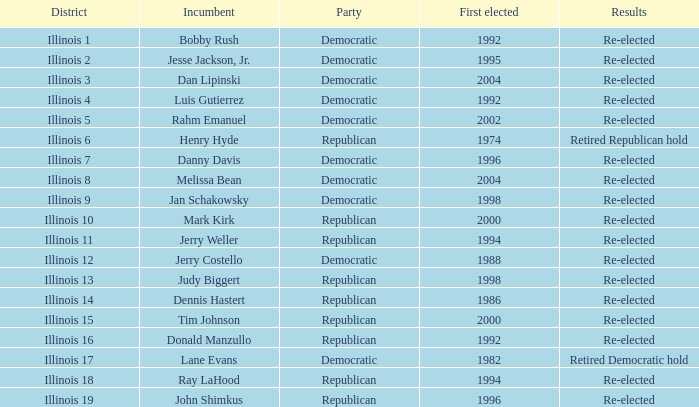What is the party of illinois district 19 with a current officeholder first elected in 1996? Republican. 